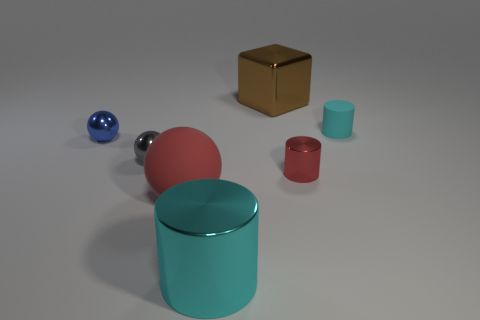There is a thing on the left side of the gray shiny ball; is its size the same as the gray thing?
Keep it short and to the point. Yes. Is there anything else that is the same shape as the blue metallic thing?
Offer a very short reply. Yes. Is the material of the brown thing the same as the cylinder that is on the left side of the cube?
Offer a terse response. Yes. How many green things are large metallic objects or objects?
Your response must be concise. 0. Is there a small gray sphere?
Offer a very short reply. Yes. There is a small metal thing that is to the left of the small sphere that is in front of the small blue shiny sphere; are there any big cyan objects that are behind it?
Provide a short and direct response. No. Is the shape of the small rubber object the same as the big object to the left of the cyan metal object?
Your response must be concise. No. What is the color of the large thing that is to the right of the large metallic object that is in front of the matte object that is to the right of the brown metallic cube?
Your answer should be very brief. Brown. How many objects are red objects that are left of the big shiny cube or small objects behind the small gray metal ball?
Provide a short and direct response. 3. How many other things are the same color as the metal cube?
Your answer should be very brief. 0. 